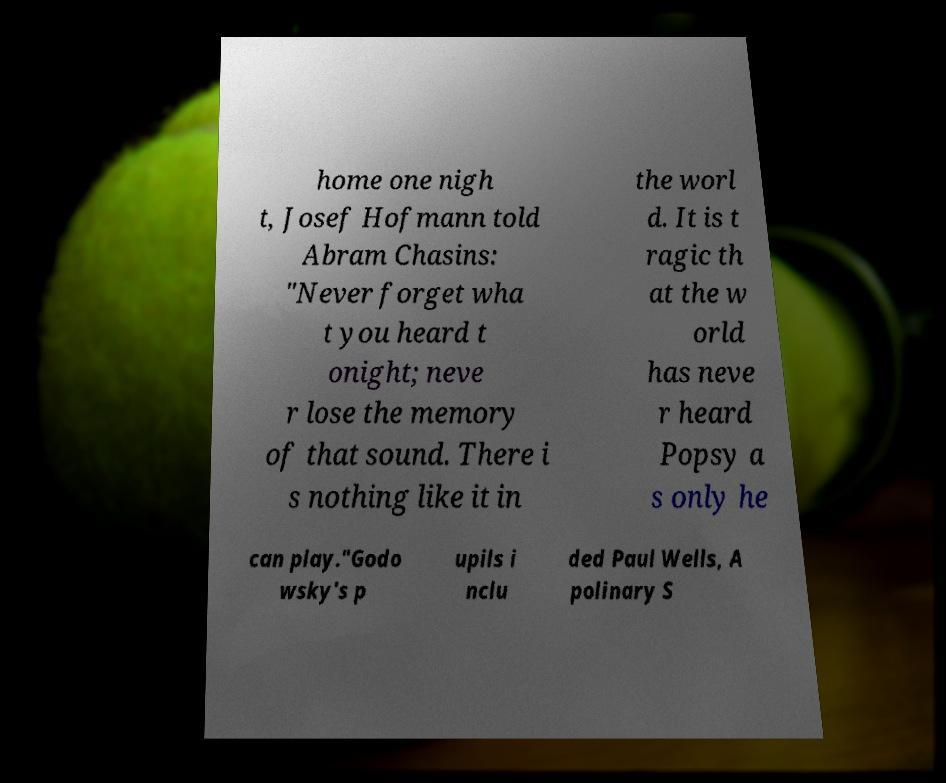For documentation purposes, I need the text within this image transcribed. Could you provide that? home one nigh t, Josef Hofmann told Abram Chasins: "Never forget wha t you heard t onight; neve r lose the memory of that sound. There i s nothing like it in the worl d. It is t ragic th at the w orld has neve r heard Popsy a s only he can play."Godo wsky's p upils i nclu ded Paul Wells, A polinary S 